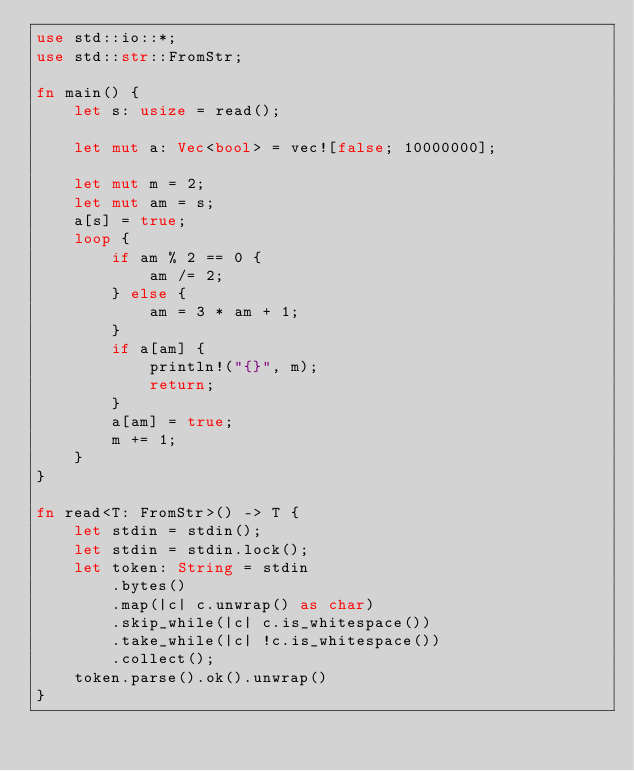<code> <loc_0><loc_0><loc_500><loc_500><_Rust_>use std::io::*;
use std::str::FromStr;

fn main() {
    let s: usize = read();

    let mut a: Vec<bool> = vec![false; 10000000];
    
    let mut m = 2;
    let mut am = s;
    a[s] = true;
    loop {
        if am % 2 == 0 {
            am /= 2;
        } else {
            am = 3 * am + 1;
        }
        if a[am] {
            println!("{}", m);
            return;
        }
        a[am] = true;
        m += 1;
    }
}

fn read<T: FromStr>() -> T {
    let stdin = stdin();
    let stdin = stdin.lock();
    let token: String = stdin
        .bytes()
        .map(|c| c.unwrap() as char)
        .skip_while(|c| c.is_whitespace())
        .take_while(|c| !c.is_whitespace())
        .collect();
    token.parse().ok().unwrap()
}
</code> 